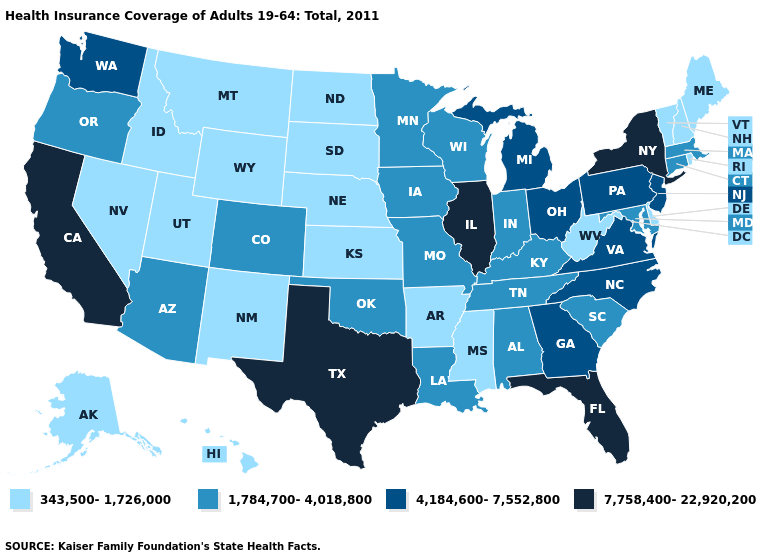Name the states that have a value in the range 343,500-1,726,000?
Keep it brief. Alaska, Arkansas, Delaware, Hawaii, Idaho, Kansas, Maine, Mississippi, Montana, Nebraska, Nevada, New Hampshire, New Mexico, North Dakota, Rhode Island, South Dakota, Utah, Vermont, West Virginia, Wyoming. Name the states that have a value in the range 4,184,600-7,552,800?
Quick response, please. Georgia, Michigan, New Jersey, North Carolina, Ohio, Pennsylvania, Virginia, Washington. What is the highest value in states that border Montana?
Short answer required. 343,500-1,726,000. Name the states that have a value in the range 7,758,400-22,920,200?
Quick response, please. California, Florida, Illinois, New York, Texas. What is the value of Missouri?
Keep it brief. 1,784,700-4,018,800. Name the states that have a value in the range 7,758,400-22,920,200?
Give a very brief answer. California, Florida, Illinois, New York, Texas. What is the lowest value in states that border Mississippi?
Be succinct. 343,500-1,726,000. Which states hav the highest value in the West?
Give a very brief answer. California. What is the highest value in the USA?
Answer briefly. 7,758,400-22,920,200. What is the value of Tennessee?
Answer briefly. 1,784,700-4,018,800. Does Michigan have a lower value than New York?
Answer briefly. Yes. What is the highest value in states that border Colorado?
Short answer required. 1,784,700-4,018,800. Does the map have missing data?
Short answer required. No. Does the first symbol in the legend represent the smallest category?
Keep it brief. Yes. 